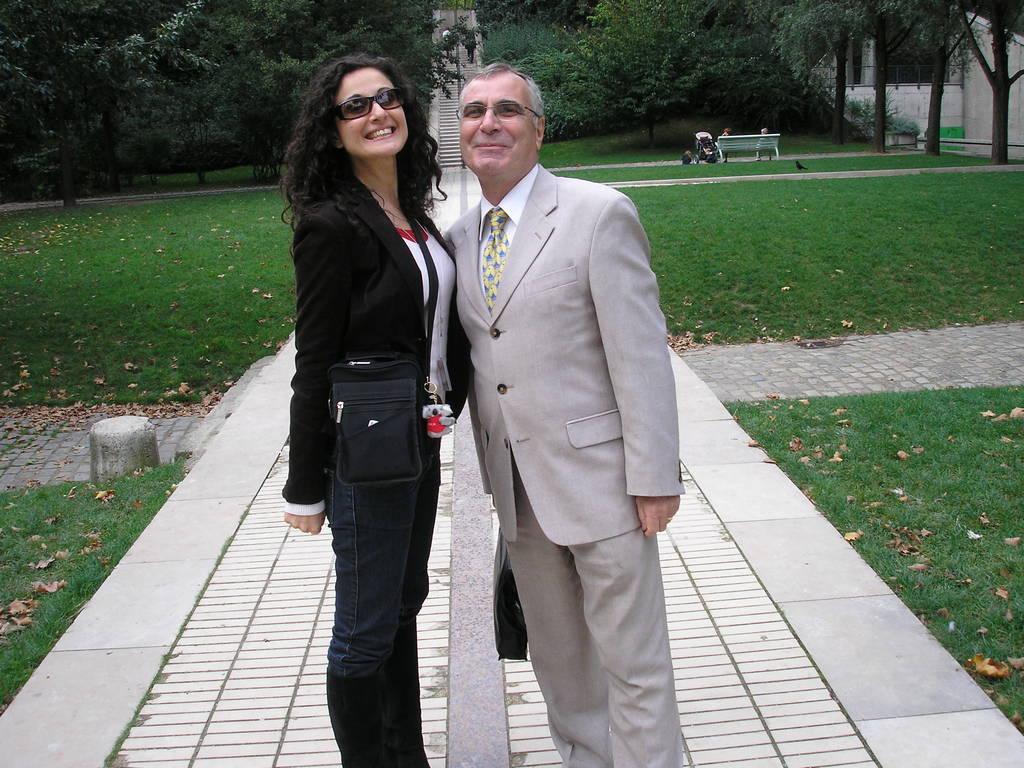Please provide a concise description of this image. In this image we can see a man and a woman standing on the walking path and smiling. In the background there are shredded leaves on the ground, people sitting on the bench, baby pram, buildings and trees. 